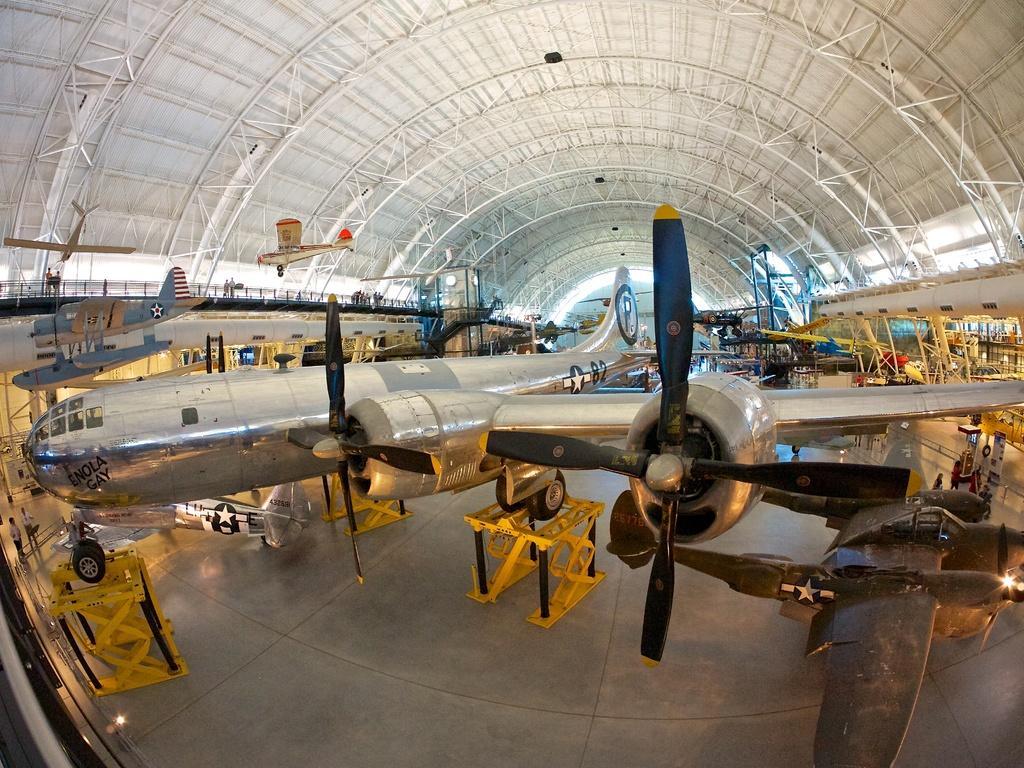How would you summarize this image in a sentence or two? There are many planes with logos on that. On the ground there are yellow color stands. On the ceiling there are rods. 